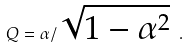<formula> <loc_0><loc_0><loc_500><loc_500>Q = \alpha / \sqrt { 1 - \alpha ^ { 2 } } \ .</formula> 